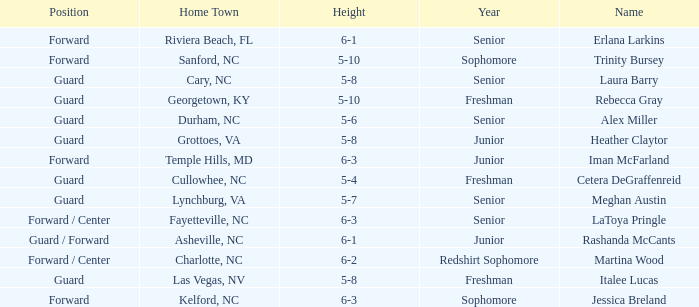What position does the 5-8 player from Grottoes, VA play? Guard. Parse the full table. {'header': ['Position', 'Home Town', 'Height', 'Year', 'Name'], 'rows': [['Forward', 'Riviera Beach, FL', '6-1', 'Senior', 'Erlana Larkins'], ['Forward', 'Sanford, NC', '5-10', 'Sophomore', 'Trinity Bursey'], ['Guard', 'Cary, NC', '5-8', 'Senior', 'Laura Barry'], ['Guard', 'Georgetown, KY', '5-10', 'Freshman', 'Rebecca Gray'], ['Guard', 'Durham, NC', '5-6', 'Senior', 'Alex Miller'], ['Guard', 'Grottoes, VA', '5-8', 'Junior', 'Heather Claytor'], ['Forward', 'Temple Hills, MD', '6-3', 'Junior', 'Iman McFarland'], ['Guard', 'Cullowhee, NC', '5-4', 'Freshman', 'Cetera DeGraffenreid'], ['Guard', 'Lynchburg, VA', '5-7', 'Senior', 'Meghan Austin'], ['Forward / Center', 'Fayetteville, NC', '6-3', 'Senior', 'LaToya Pringle'], ['Guard / Forward', 'Asheville, NC', '6-1', 'Junior', 'Rashanda McCants'], ['Forward / Center', 'Charlotte, NC', '6-2', 'Redshirt Sophomore', 'Martina Wood'], ['Guard', 'Las Vegas, NV', '5-8', 'Freshman', 'Italee Lucas'], ['Forward', 'Kelford, NC', '6-3', 'Sophomore', 'Jessica Breland']]} 